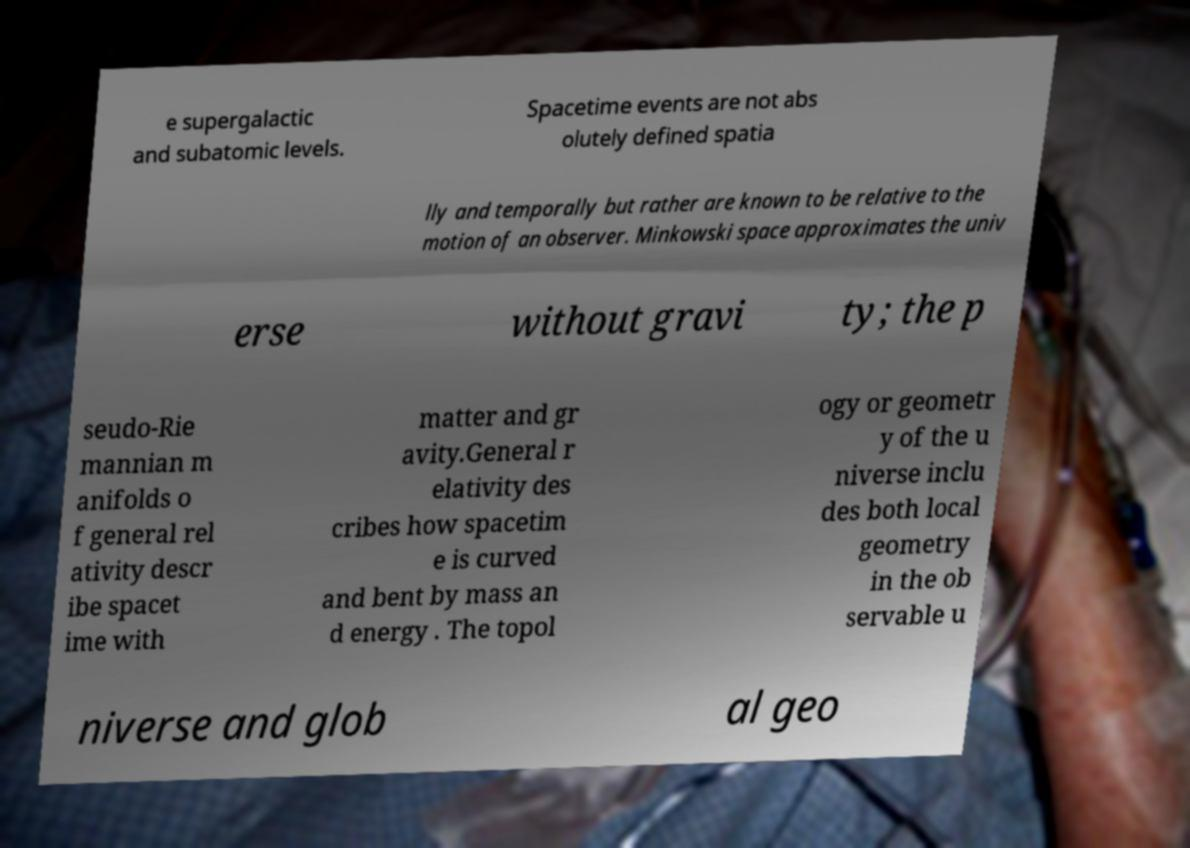For documentation purposes, I need the text within this image transcribed. Could you provide that? e supergalactic and subatomic levels. Spacetime events are not abs olutely defined spatia lly and temporally but rather are known to be relative to the motion of an observer. Minkowski space approximates the univ erse without gravi ty; the p seudo-Rie mannian m anifolds o f general rel ativity descr ibe spacet ime with matter and gr avity.General r elativity des cribes how spacetim e is curved and bent by mass an d energy . The topol ogy or geometr y of the u niverse inclu des both local geometry in the ob servable u niverse and glob al geo 